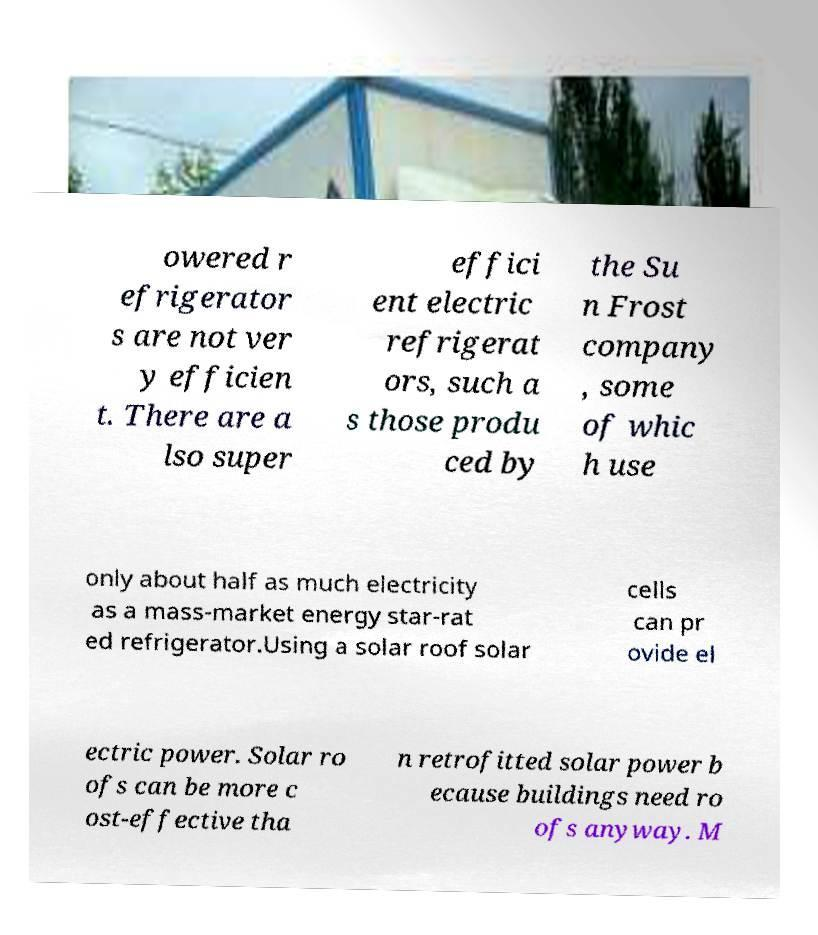Please read and relay the text visible in this image. What does it say? owered r efrigerator s are not ver y efficien t. There are a lso super effici ent electric refrigerat ors, such a s those produ ced by the Su n Frost company , some of whic h use only about half as much electricity as a mass-market energy star-rat ed refrigerator.Using a solar roof solar cells can pr ovide el ectric power. Solar ro ofs can be more c ost-effective tha n retrofitted solar power b ecause buildings need ro ofs anyway. M 